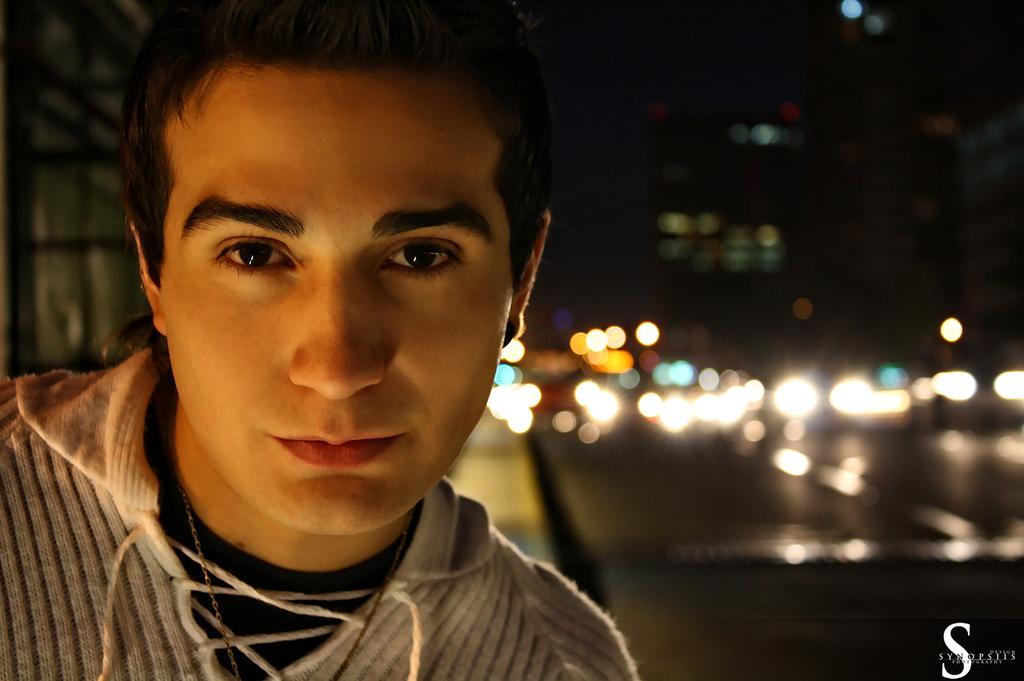Could you give a brief overview of what you see in this image? In this image I can see the person with the white and black color dress. To the side there are many lights. And there is a blurred background. 